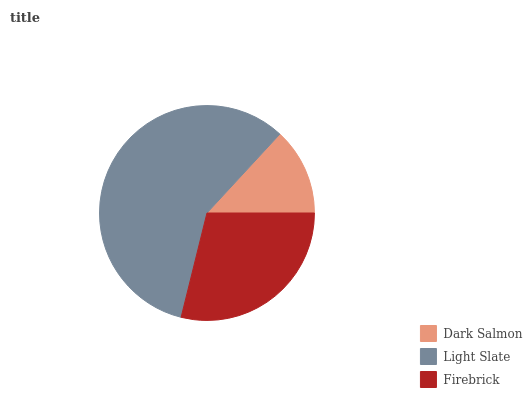Is Dark Salmon the minimum?
Answer yes or no. Yes. Is Light Slate the maximum?
Answer yes or no. Yes. Is Firebrick the minimum?
Answer yes or no. No. Is Firebrick the maximum?
Answer yes or no. No. Is Light Slate greater than Firebrick?
Answer yes or no. Yes. Is Firebrick less than Light Slate?
Answer yes or no. Yes. Is Firebrick greater than Light Slate?
Answer yes or no. No. Is Light Slate less than Firebrick?
Answer yes or no. No. Is Firebrick the high median?
Answer yes or no. Yes. Is Firebrick the low median?
Answer yes or no. Yes. Is Dark Salmon the high median?
Answer yes or no. No. Is Dark Salmon the low median?
Answer yes or no. No. 